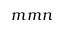<formula> <loc_0><loc_0><loc_500><loc_500>m m n</formula> 